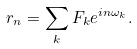<formula> <loc_0><loc_0><loc_500><loc_500>r _ { n } = \sum _ { k } F _ { k } e ^ { i n \omega _ { k } } .</formula> 